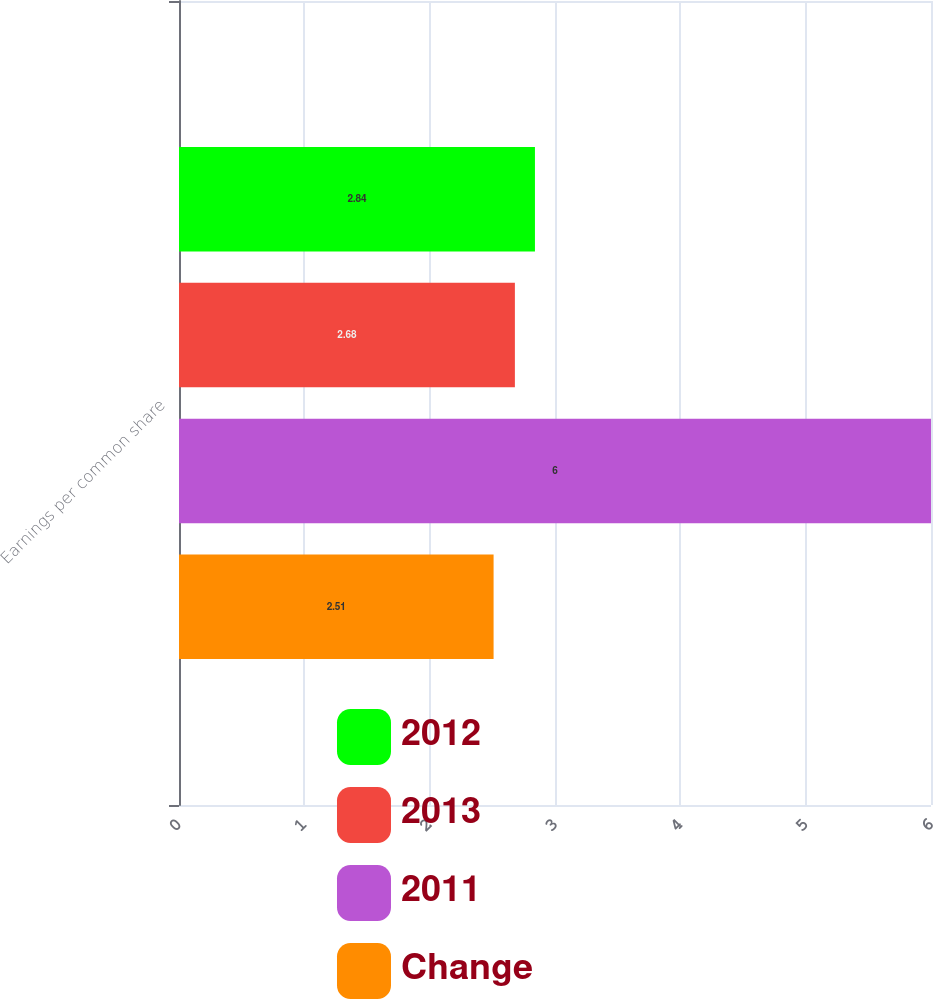<chart> <loc_0><loc_0><loc_500><loc_500><stacked_bar_chart><ecel><fcel>Earnings per common share<nl><fcel>2012<fcel>2.84<nl><fcel>2013<fcel>2.68<nl><fcel>2011<fcel>6<nl><fcel>Change<fcel>2.51<nl></chart> 